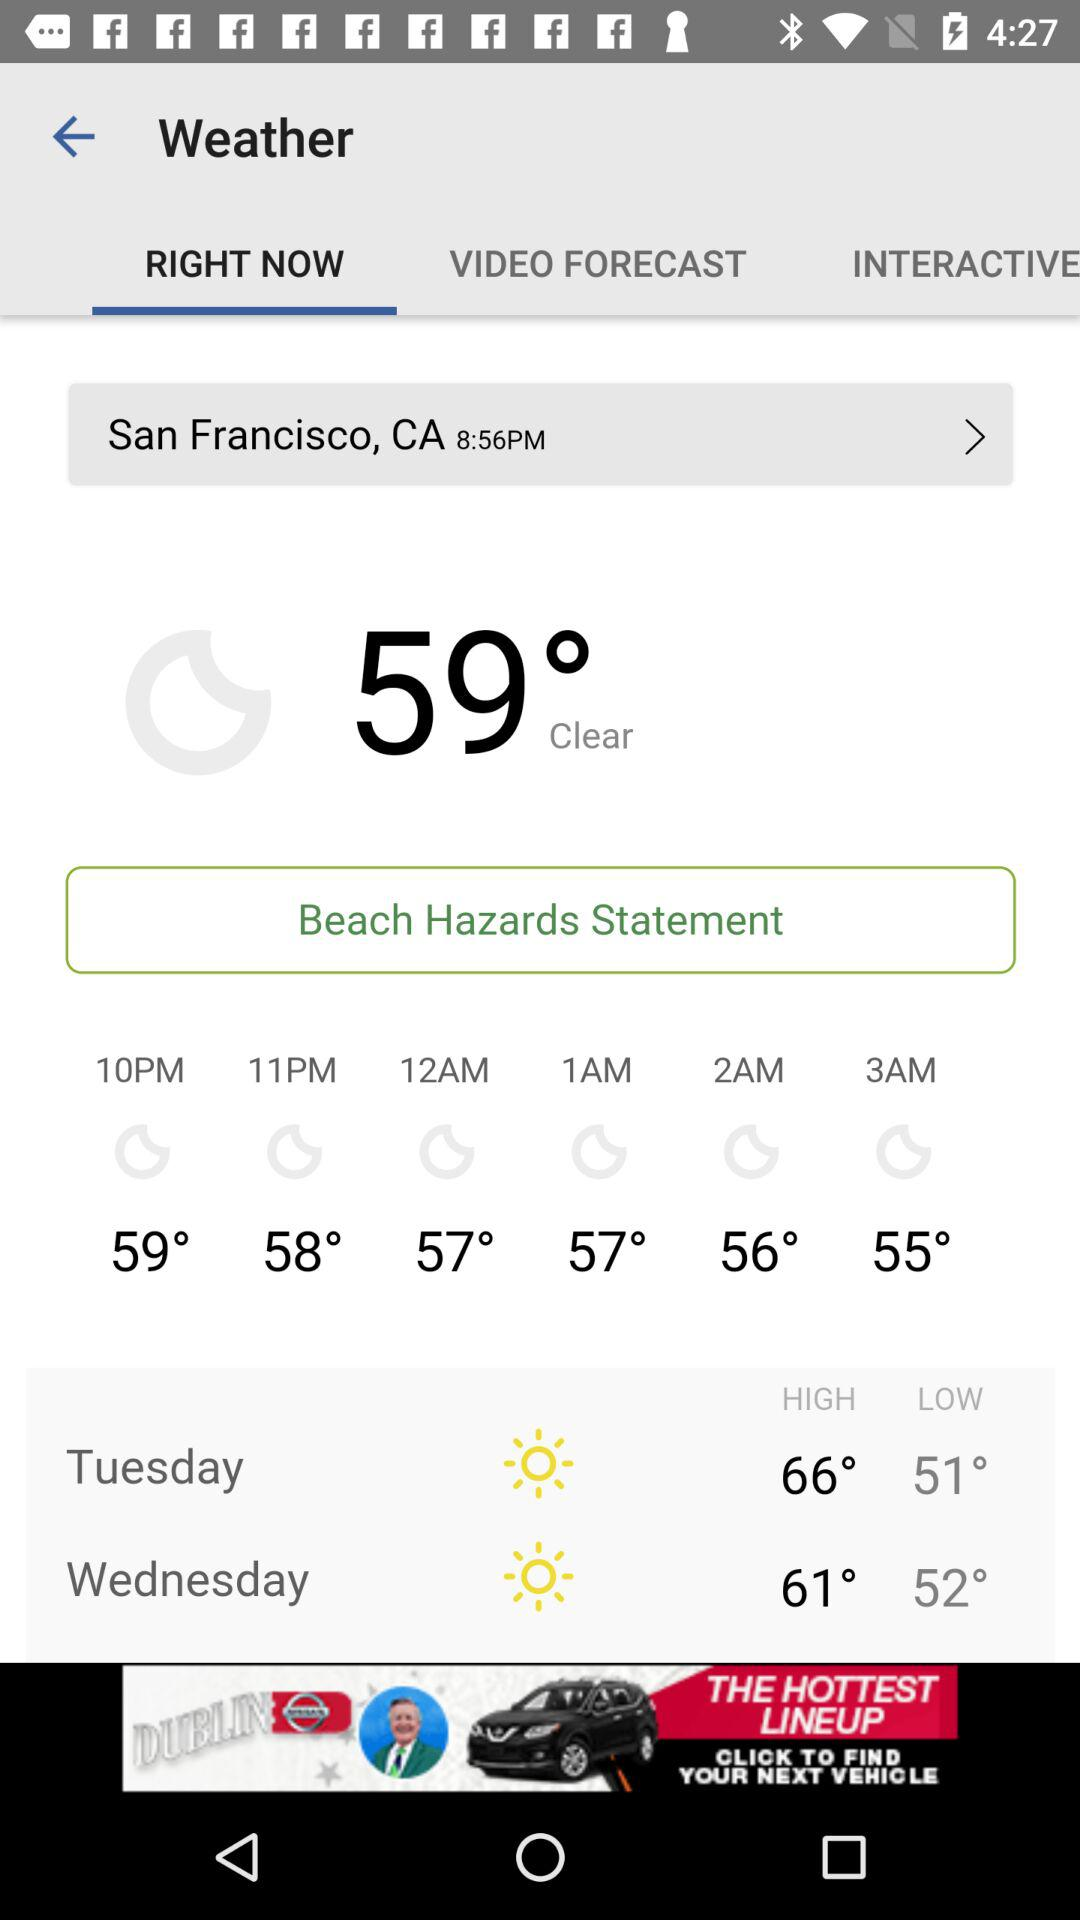At what time is the temperature low? The temperature is low at 3 AM. 